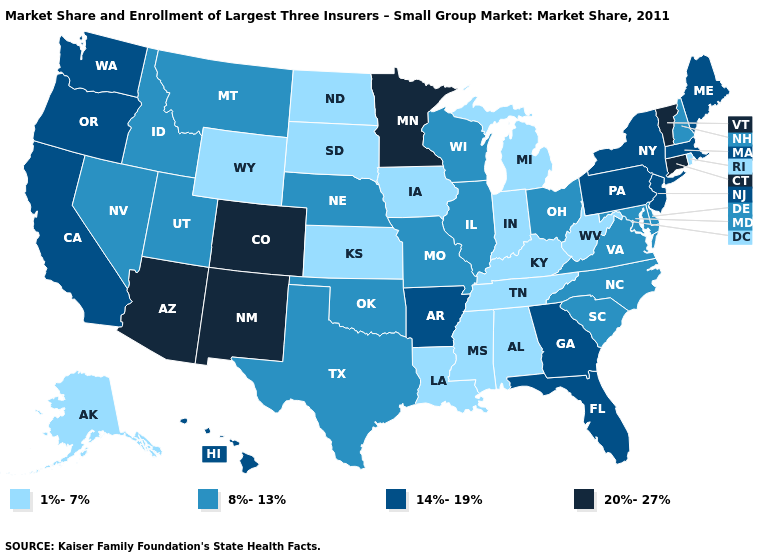What is the value of Alabama?
Answer briefly. 1%-7%. Does South Dakota have the highest value in the USA?
Concise answer only. No. Does Rhode Island have a lower value than Kansas?
Concise answer only. No. Does Kansas have the lowest value in the USA?
Keep it brief. Yes. Does the first symbol in the legend represent the smallest category?
Keep it brief. Yes. Does Oregon have the highest value in the West?
Quick response, please. No. What is the lowest value in states that border New Hampshire?
Answer briefly. 14%-19%. Which states have the lowest value in the USA?
Write a very short answer. Alabama, Alaska, Indiana, Iowa, Kansas, Kentucky, Louisiana, Michigan, Mississippi, North Dakota, Rhode Island, South Dakota, Tennessee, West Virginia, Wyoming. What is the value of Alaska?
Keep it brief. 1%-7%. Is the legend a continuous bar?
Quick response, please. No. Name the states that have a value in the range 14%-19%?
Give a very brief answer. Arkansas, California, Florida, Georgia, Hawaii, Maine, Massachusetts, New Jersey, New York, Oregon, Pennsylvania, Washington. Name the states that have a value in the range 14%-19%?
Concise answer only. Arkansas, California, Florida, Georgia, Hawaii, Maine, Massachusetts, New Jersey, New York, Oregon, Pennsylvania, Washington. What is the lowest value in states that border Montana?
Keep it brief. 1%-7%. Which states have the lowest value in the MidWest?
Be succinct. Indiana, Iowa, Kansas, Michigan, North Dakota, South Dakota. What is the highest value in the Northeast ?
Short answer required. 20%-27%. 